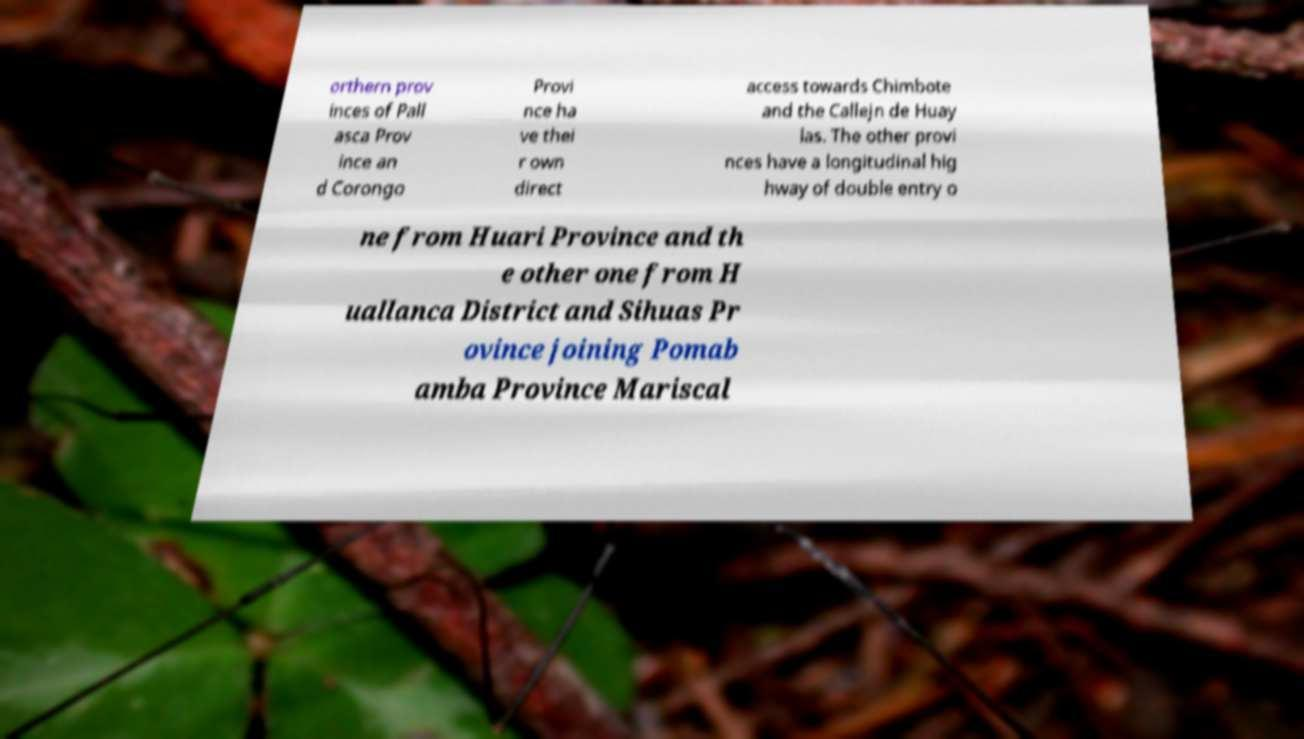Could you extract and type out the text from this image? orthern prov inces of Pall asca Prov ince an d Corongo Provi nce ha ve thei r own direct access towards Chimbote and the Callejn de Huay las. The other provi nces have a longitudinal hig hway of double entry o ne from Huari Province and th e other one from H uallanca District and Sihuas Pr ovince joining Pomab amba Province Mariscal 